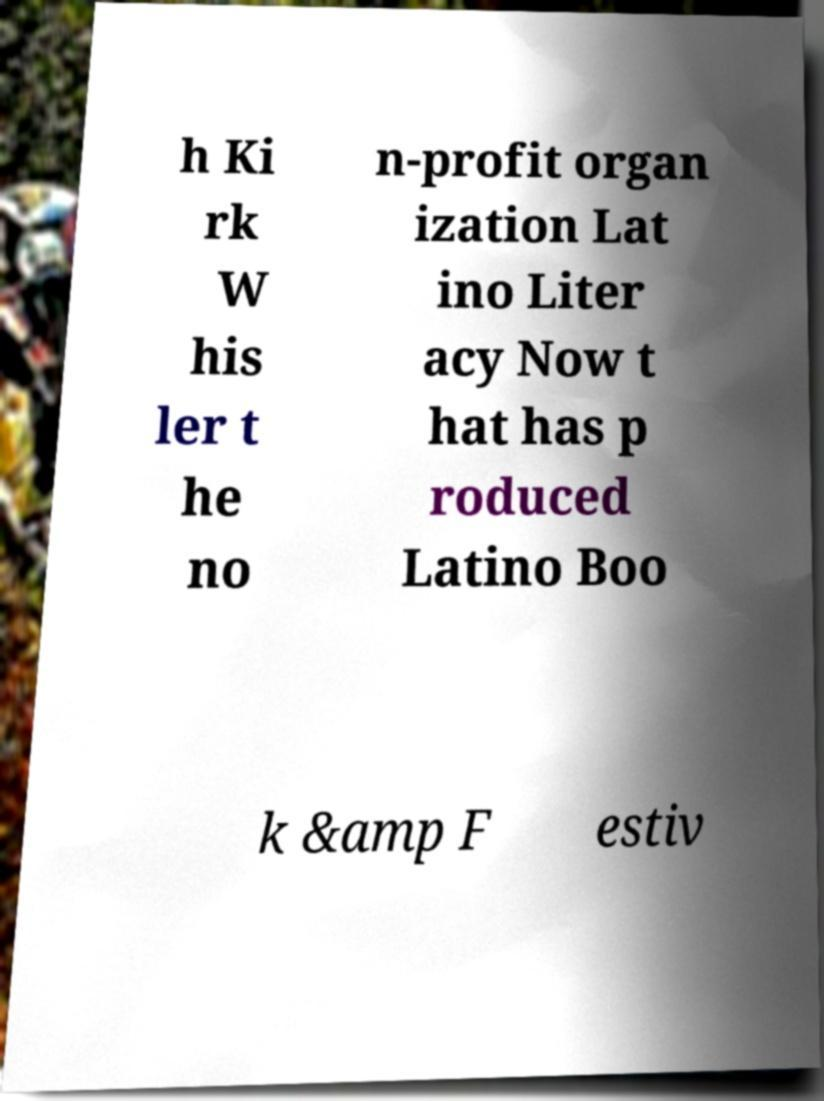Please read and relay the text visible in this image. What does it say? h Ki rk W his ler t he no n-profit organ ization Lat ino Liter acy Now t hat has p roduced Latino Boo k &amp F estiv 